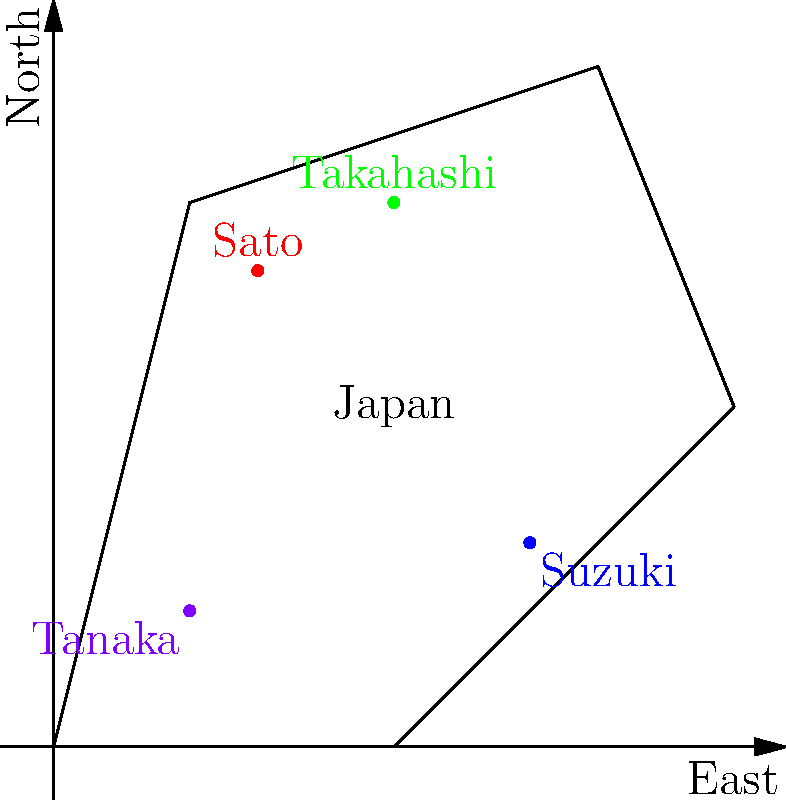Based on the map of Japan showing the regional prevalence of common Japanese surnames, which family name appears to be most prevalent in the southwestern region of the country? To answer this question, we need to analyze the map and the distribution of family names:

1. The map shows a simplified outline of Japan with four family names plotted:
   - Sato (red dot) in the northern region
   - Suzuki (blue dot) in the eastern region
   - Takahashi (green dot) in the northern region
   - Tanaka (purple dot) in the southwestern region

2. We need to identify which name is positioned in the southwestern part of the map.

3. Looking at the southwestern area (lower left quadrant of the map), we can see a purple dot.

4. This purple dot is labeled "Tanaka".

5. The position of the Tanaka label in the southwestern region indicates that this surname is most prevalent in that area of Japan.

6. The other family names are located in different regions:
   - Sato and Takahashi are in the north
   - Suzuki is in the east

Therefore, based on the given map, the family name Tanaka appears to be most prevalent in the southwestern region of Japan.
Answer: Tanaka 